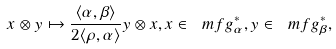<formula> <loc_0><loc_0><loc_500><loc_500>x \otimes y \mapsto \frac { \langle \alpha , \beta \rangle } { 2 \langle \rho , \alpha \rangle } y \otimes x , x \in \ m f g _ { \alpha } ^ { * } , y \in \ m f g _ { \beta } ^ { * } ,</formula> 